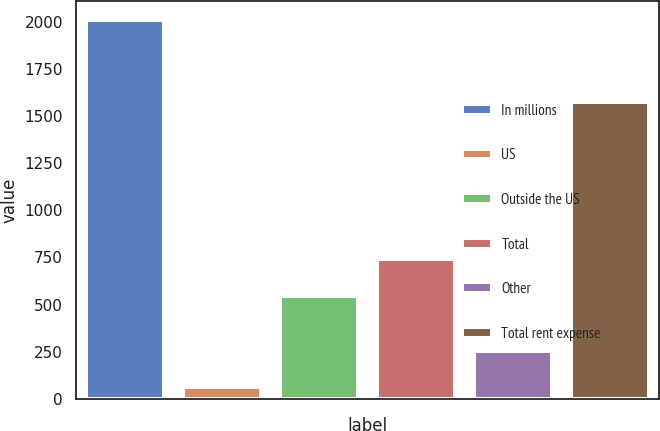Convert chart. <chart><loc_0><loc_0><loc_500><loc_500><bar_chart><fcel>In millions<fcel>US<fcel>Outside the US<fcel>Total<fcel>Other<fcel>Total rent expense<nl><fcel>2010<fcel>60.4<fcel>545<fcel>739.96<fcel>255.36<fcel>1576.7<nl></chart> 